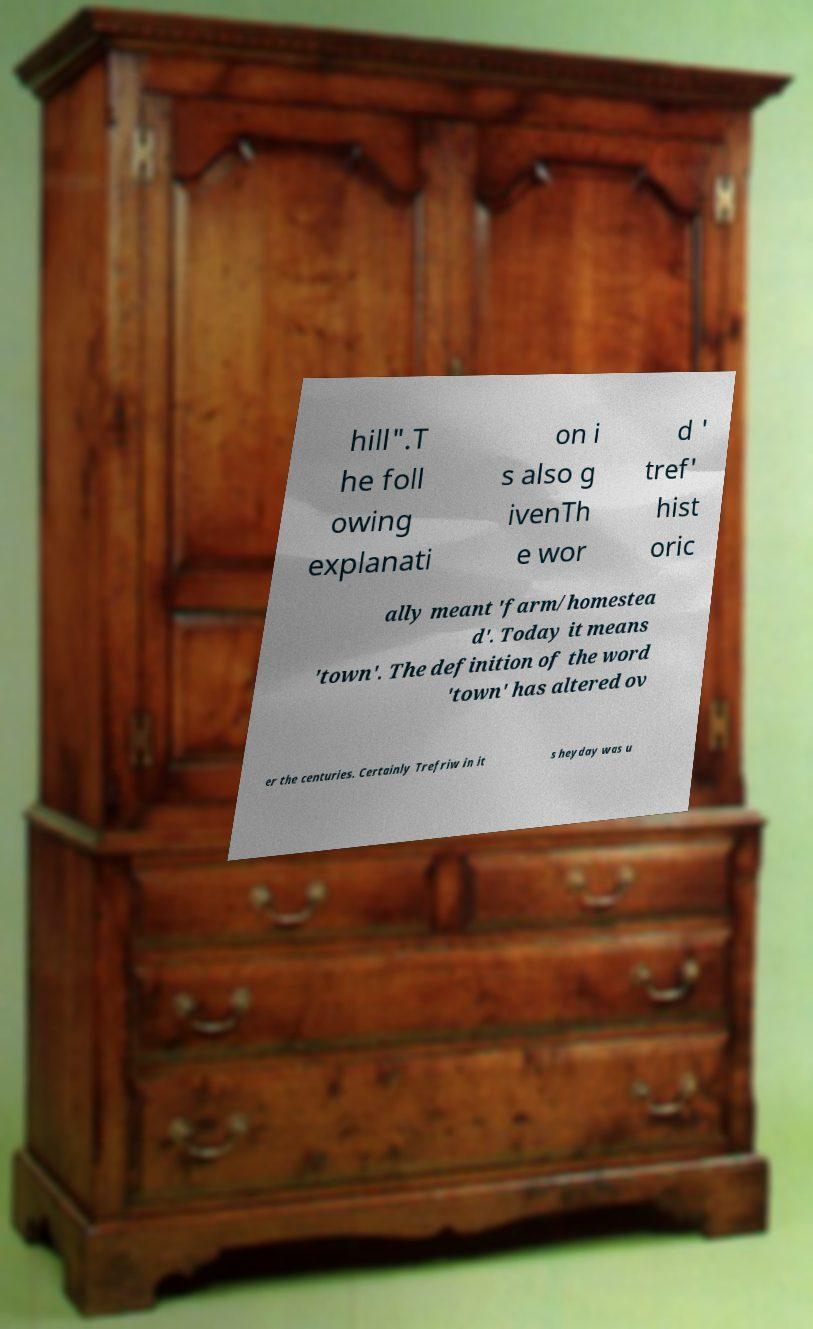Could you extract and type out the text from this image? hill".T he foll owing explanati on i s also g ivenTh e wor d ' tref' hist oric ally meant 'farm/homestea d'. Today it means 'town'. The definition of the word 'town' has altered ov er the centuries. Certainly Trefriw in it s heyday was u 